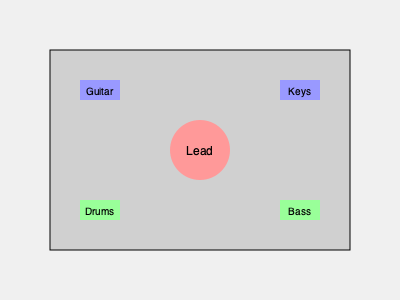In the given stage layout for a live performance, which instrument placement would likely cause the most issues with sound balance and why? To answer this question, let's analyze the stage layout step-by-step:

1. The layout shows a typical band setup with lead vocals in the center, guitar and keys on either side at the front, and drums and bass at the back.

2. Sound balance is crucial in live performances, and instrument placement plays a significant role in achieving this balance.

3. The drums are typically the loudest acoustic instrument on stage, capable of overpowering other instruments if not properly managed.

4. In this layout, the drums are positioned at the back left of the stage. This placement is generally good as it allows the drum sound to project across the stage without directly overwhelming the other musicians.

5. However, the bass guitar is positioned at the back right, directly opposite the drums. This placement can cause several issues:

   a) Bass frequencies are omnidirectional and can easily overpower other instruments.
   b) Having the bass and drums on opposite sides can create a "ping-pong" effect, where the rhythm section sounds disjointed.
   c) This separation can make it difficult for the bass player and drummer to lock in rhythmically, which is crucial for a tight performance.

6. Ideally, the bass should be positioned closer to the drums to create a tighter rhythm section and better overall sound balance.

Therefore, the bass guitar placement is likely to cause the most issues with sound balance in this layout.
Answer: Bass guitar placement 